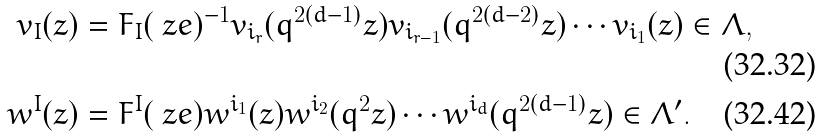<formula> <loc_0><loc_0><loc_500><loc_500>v _ { I } ( z ) & = F _ { I } ( \ z e ) ^ { - 1 } v _ { i _ { r } } ( q ^ { 2 ( d - 1 ) } z ) v _ { i _ { r - 1 } } ( q ^ { 2 ( d - 2 ) } z ) \cdots v _ { i _ { 1 } } ( z ) \in \Lambda , \\ w ^ { I } ( z ) & = F ^ { I } ( \ z e ) w ^ { i _ { 1 } } ( z ) w ^ { i _ { 2 } } ( q ^ { 2 } z ) \cdots w ^ { i _ { d } } ( q ^ { 2 ( d - 1 ) } z ) \in \Lambda ^ { \prime } .</formula> 